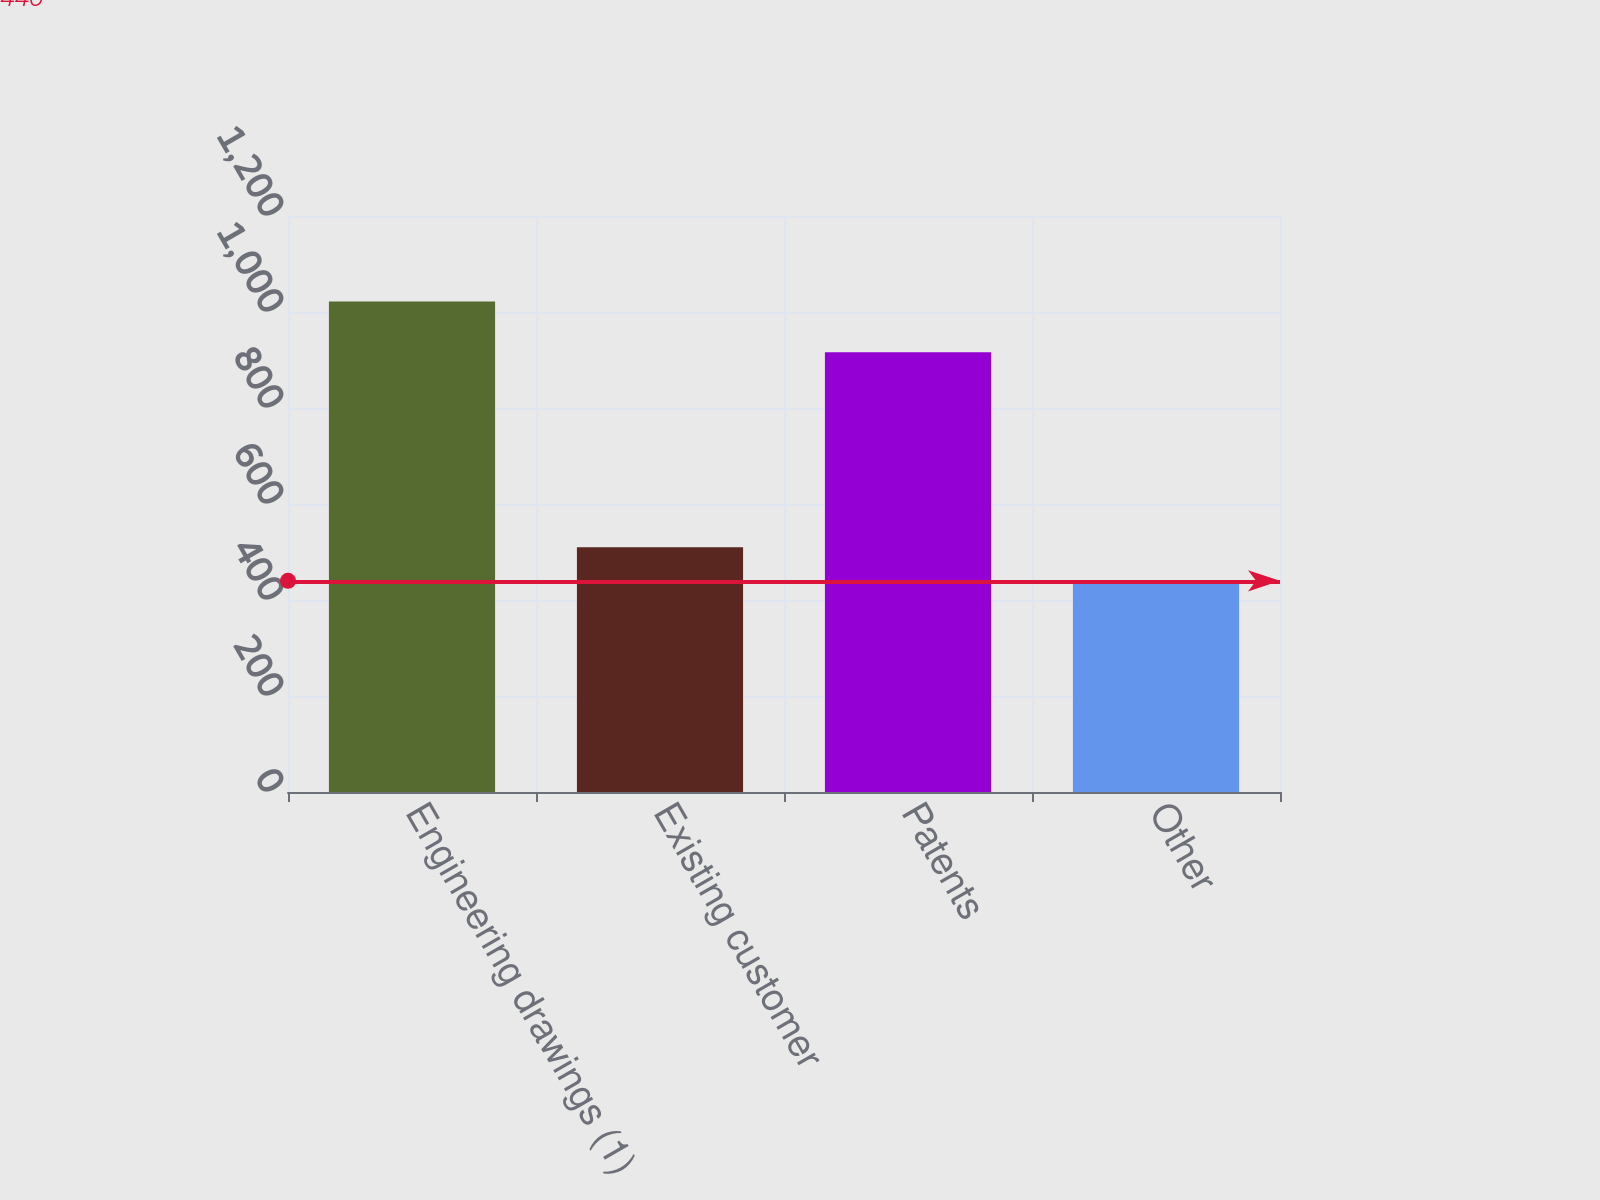<chart> <loc_0><loc_0><loc_500><loc_500><bar_chart><fcel>Engineering drawings (1)<fcel>Existing customer<fcel>Patents<fcel>Other<nl><fcel>1022<fcel>510<fcel>916<fcel>440<nl></chart> 